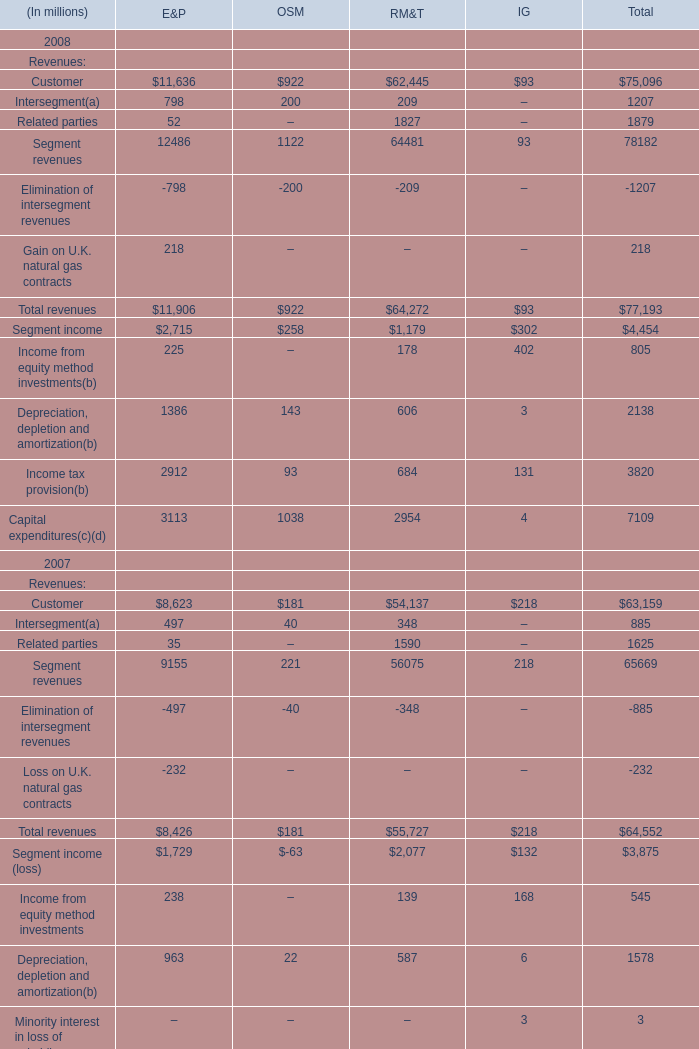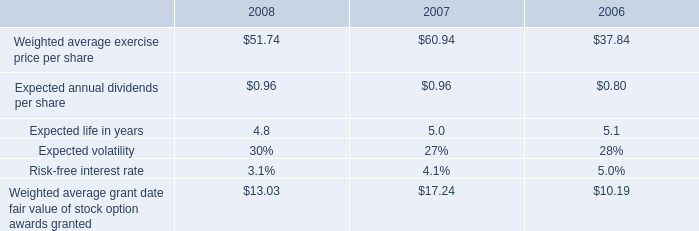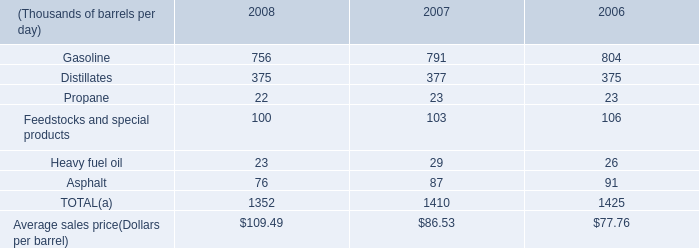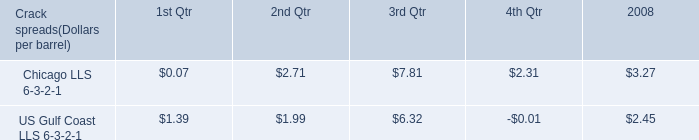by what percentage did the company's weighted average exercise price per share increase from 2006 to 2008? 
Computations: ((51.74 - 37.84) / 37.84)
Answer: 0.36734. 